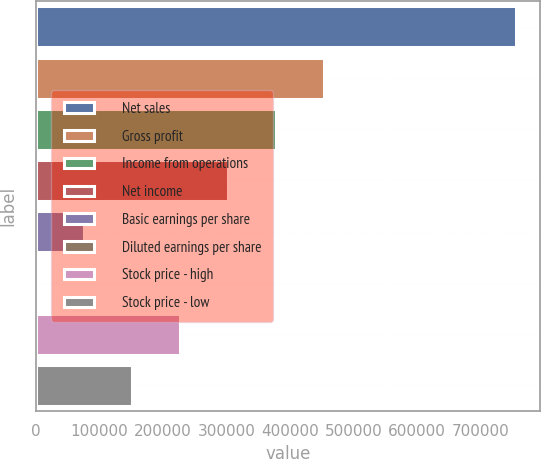Convert chart. <chart><loc_0><loc_0><loc_500><loc_500><bar_chart><fcel>Net sales<fcel>Gross profit<fcel>Income from operations<fcel>Net income<fcel>Basic earnings per share<fcel>Diluted earnings per share<fcel>Stock price - high<fcel>Stock price - low<nl><fcel>755207<fcel>453124<fcel>377604<fcel>302083<fcel>75521.3<fcel>0.62<fcel>226563<fcel>151042<nl></chart> 